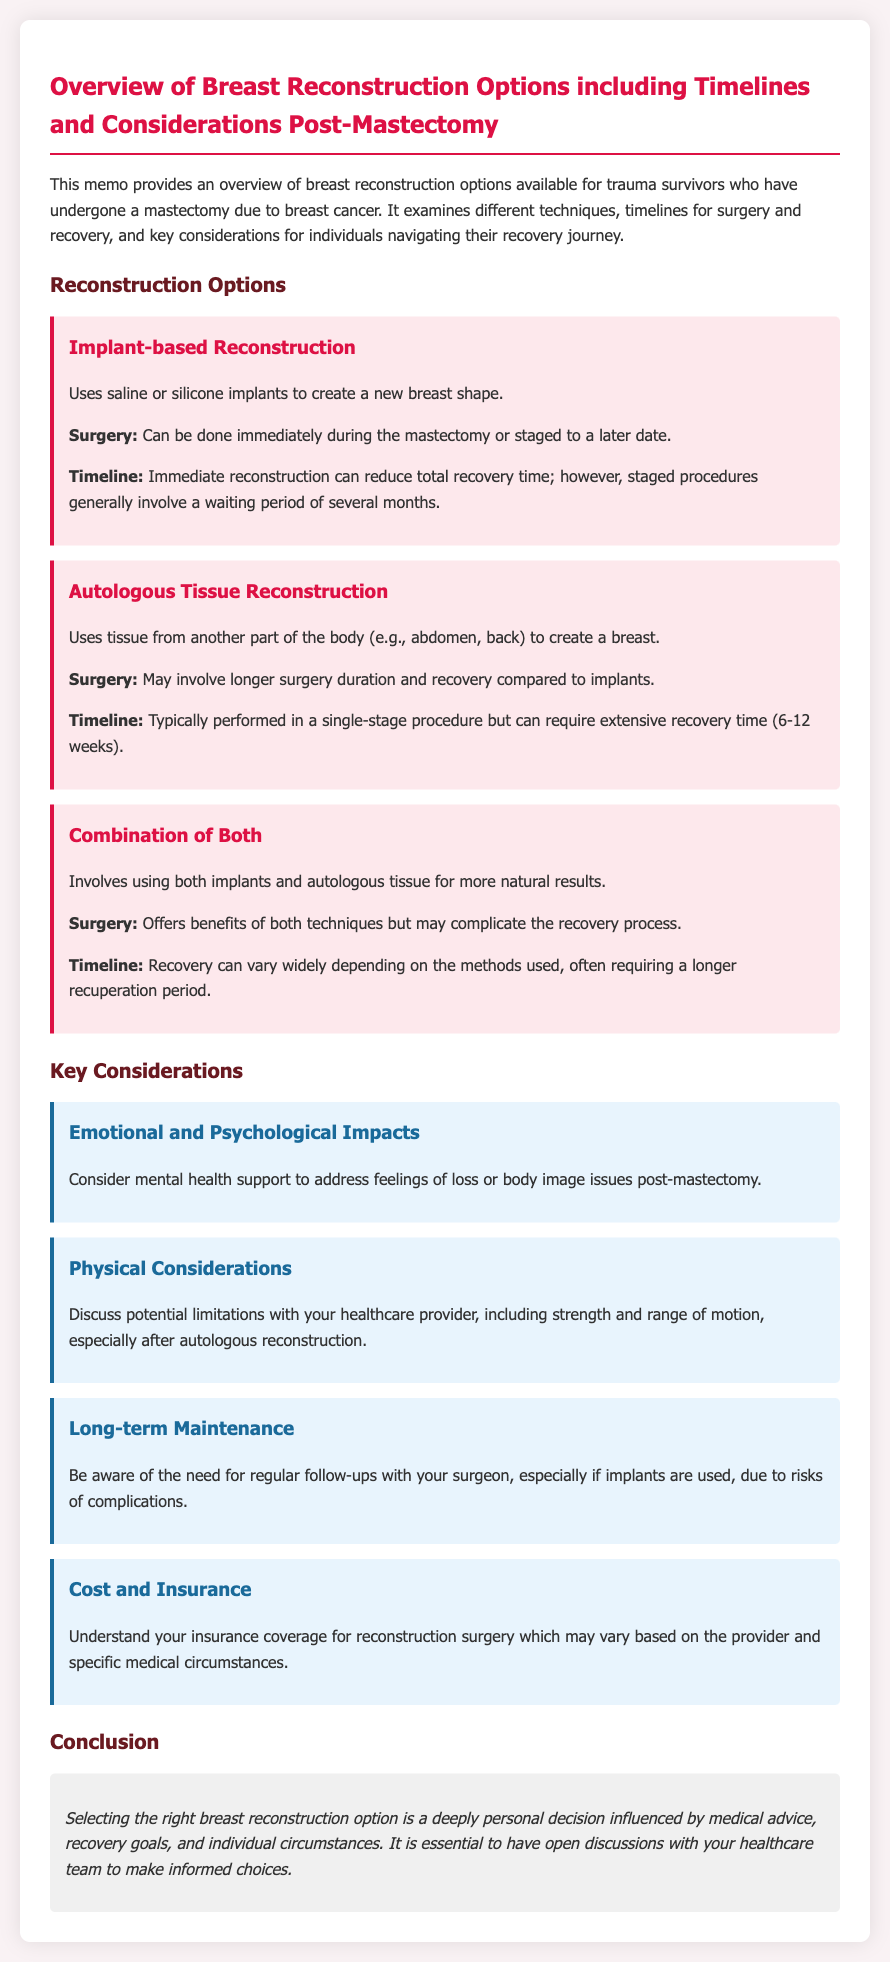What are the types of reconstruction options mentioned? The document lists the reconstruction options as Implant-based Reconstruction, Autologous Tissue Reconstruction, and Combination of Both.
Answer: Implant-based Reconstruction, Autologous Tissue Reconstruction, Combination of Both What type of reconstruction may involve longer surgery and recovery? The document states that Autologous Tissue Reconstruction may involve longer surgery duration and recovery compared to implants.
Answer: Autologous Tissue Reconstruction What is the typical recovery time after Autologous Tissue Reconstruction? The document specifies that recovery time can be 6-12 weeks after Autologous Tissue Reconstruction.
Answer: 6-12 weeks What emotional aspect should be considered post-mastectomy? The document states that mental health support to address feelings of loss or body image issues is an important emotional consideration post-mastectomy.
Answer: Mental health support Why is it important to have follow-ups with the surgeon? The document mentions that regular follow-ups are important, especially if implants are used, due to risks of complications.
Answer: Risks of complications What is a key factor influenced by medical advice when selecting reconstruction options? The document highlights that selecting the right breast reconstruction option is influenced by medical advice, recovery goals, and individual circumstances.
Answer: Medical advice 